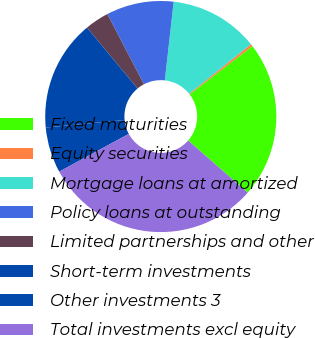Convert chart. <chart><loc_0><loc_0><loc_500><loc_500><pie_chart><fcel>Fixed maturities<fcel>Equity securities<fcel>Mortgage loans at amortized<fcel>Policy loans at outstanding<fcel>Limited partnerships and other<fcel>Short-term investments<fcel>Other investments 3<fcel>Total investments excl equity<nl><fcel>21.86%<fcel>0.34%<fcel>12.46%<fcel>9.43%<fcel>3.37%<fcel>15.49%<fcel>6.4%<fcel>30.64%<nl></chart> 